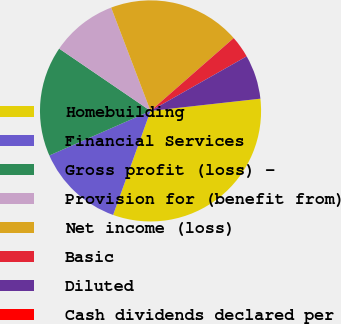<chart> <loc_0><loc_0><loc_500><loc_500><pie_chart><fcel>Homebuilding<fcel>Financial Services<fcel>Gross profit (loss) -<fcel>Provision for (benefit from)<fcel>Net income (loss)<fcel>Basic<fcel>Diluted<fcel>Cash dividends declared per<nl><fcel>32.26%<fcel>12.9%<fcel>16.13%<fcel>9.68%<fcel>19.35%<fcel>3.23%<fcel>6.45%<fcel>0.0%<nl></chart> 